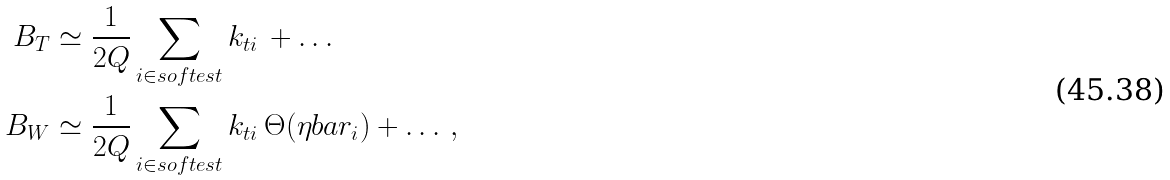Convert formula to latex. <formula><loc_0><loc_0><loc_500><loc_500>B _ { T } & \simeq \frac { 1 } { 2 Q } \sum _ { i \in s o f t e s t } k _ { t i } \, + \dots \\ B _ { W } & \simeq \frac { 1 } { 2 Q } \sum _ { i \in s o f t e s t } k _ { t i } \, \Theta ( \eta b a r _ { i } ) + \dots \, ,</formula> 